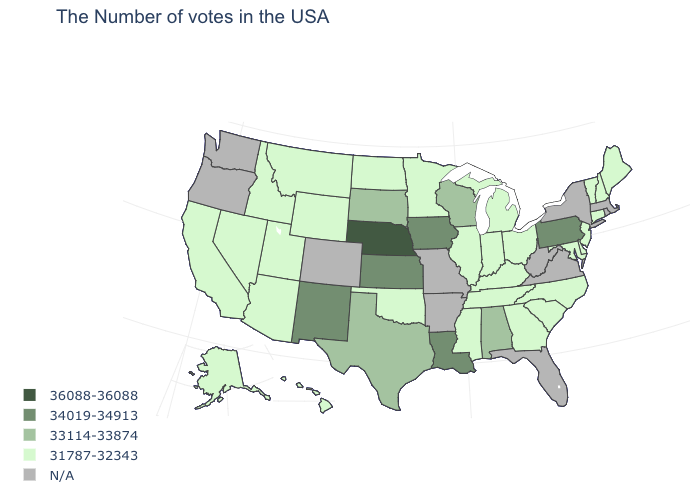Among the states that border Nebraska , which have the lowest value?
Concise answer only. Wyoming. What is the value of West Virginia?
Give a very brief answer. N/A. Does the map have missing data?
Quick response, please. Yes. Name the states that have a value in the range 31787-32343?
Write a very short answer. Maine, New Hampshire, Vermont, Connecticut, New Jersey, Delaware, Maryland, North Carolina, South Carolina, Ohio, Georgia, Michigan, Kentucky, Indiana, Tennessee, Illinois, Mississippi, Minnesota, Oklahoma, North Dakota, Wyoming, Utah, Montana, Arizona, Idaho, Nevada, California, Alaska, Hawaii. What is the highest value in the USA?
Short answer required. 36088-36088. Does the map have missing data?
Write a very short answer. Yes. Does New Mexico have the highest value in the West?
Be succinct. Yes. What is the value of Florida?
Write a very short answer. N/A. What is the value of Ohio?
Short answer required. 31787-32343. What is the lowest value in the USA?
Concise answer only. 31787-32343. Name the states that have a value in the range 34019-34913?
Write a very short answer. Pennsylvania, Louisiana, Iowa, Kansas, New Mexico. What is the value of Arkansas?
Short answer required. N/A. Does the first symbol in the legend represent the smallest category?
Keep it brief. No. What is the highest value in the USA?
Answer briefly. 36088-36088. What is the value of Colorado?
Short answer required. N/A. 